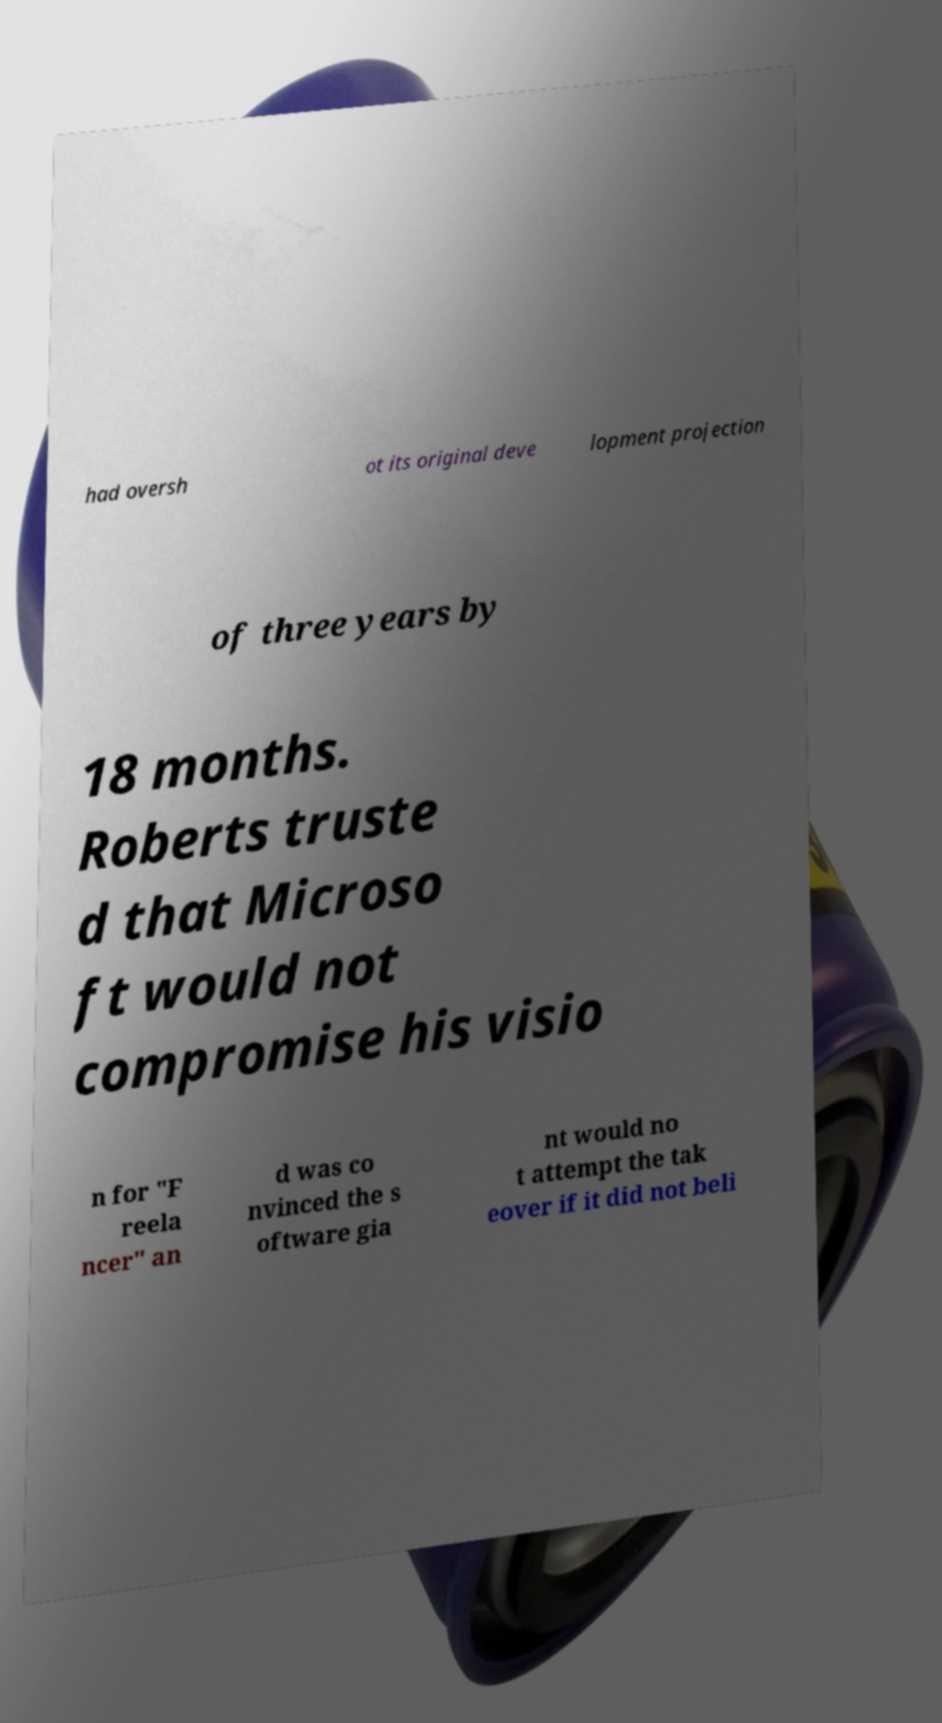What messages or text are displayed in this image? I need them in a readable, typed format. had oversh ot its original deve lopment projection of three years by 18 months. Roberts truste d that Microso ft would not compromise his visio n for "F reela ncer" an d was co nvinced the s oftware gia nt would no t attempt the tak eover if it did not beli 